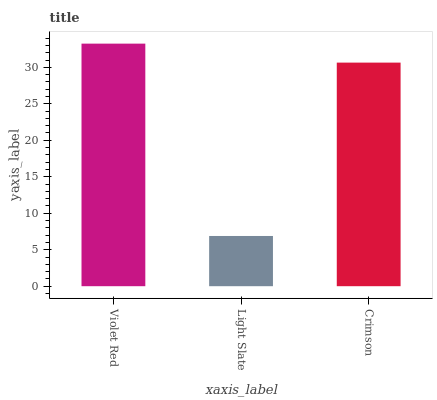Is Light Slate the minimum?
Answer yes or no. Yes. Is Violet Red the maximum?
Answer yes or no. Yes. Is Crimson the minimum?
Answer yes or no. No. Is Crimson the maximum?
Answer yes or no. No. Is Crimson greater than Light Slate?
Answer yes or no. Yes. Is Light Slate less than Crimson?
Answer yes or no. Yes. Is Light Slate greater than Crimson?
Answer yes or no. No. Is Crimson less than Light Slate?
Answer yes or no. No. Is Crimson the high median?
Answer yes or no. Yes. Is Crimson the low median?
Answer yes or no. Yes. Is Violet Red the high median?
Answer yes or no. No. Is Light Slate the low median?
Answer yes or no. No. 